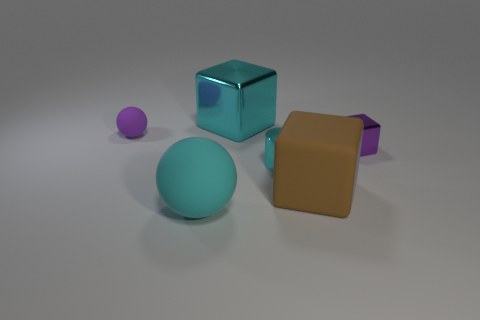Add 1 cylinders. How many objects exist? 7 Subtract all spheres. How many objects are left? 4 Add 5 rubber objects. How many rubber objects exist? 8 Subtract 0 red balls. How many objects are left? 6 Subtract all big yellow matte cylinders. Subtract all small cylinders. How many objects are left? 5 Add 2 brown cubes. How many brown cubes are left? 3 